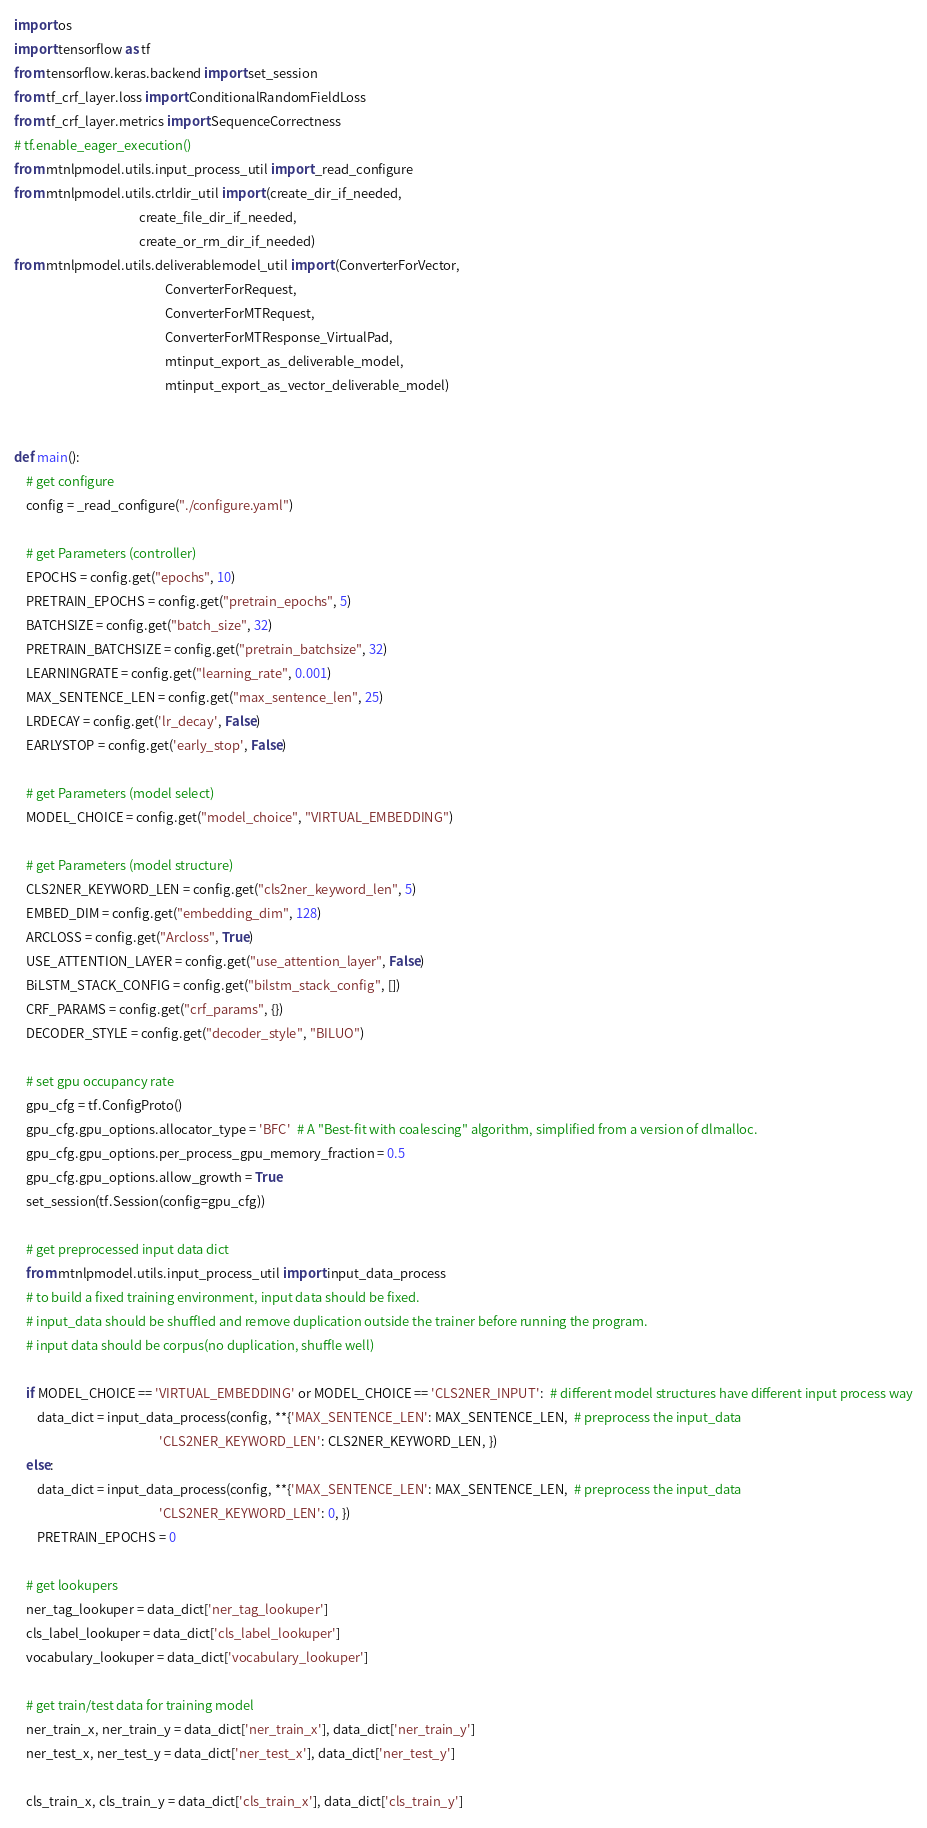Convert code to text. <code><loc_0><loc_0><loc_500><loc_500><_Python_>import os
import tensorflow as tf
from tensorflow.keras.backend import set_session
from tf_crf_layer.loss import ConditionalRandomFieldLoss
from tf_crf_layer.metrics import SequenceCorrectness
# tf.enable_eager_execution()
from mtnlpmodel.utils.input_process_util import _read_configure
from mtnlpmodel.utils.ctrldir_util import (create_dir_if_needed,
                                           create_file_dir_if_needed,
                                           create_or_rm_dir_if_needed)
from mtnlpmodel.utils.deliverablemodel_util import (ConverterForVector,
                                                    ConverterForRequest,
                                                    ConverterForMTRequest,
                                                    ConverterForMTResponse_VirtualPad,
                                                    mtinput_export_as_deliverable_model,
                                                    mtinput_export_as_vector_deliverable_model)


def main():
    # get configure
    config = _read_configure("./configure.yaml")

    # get Parameters (controller)
    EPOCHS = config.get("epochs", 10)
    PRETRAIN_EPOCHS = config.get("pretrain_epochs", 5)
    BATCHSIZE = config.get("batch_size", 32)
    PRETRAIN_BATCHSIZE = config.get("pretrain_batchsize", 32)
    LEARNINGRATE = config.get("learning_rate", 0.001)
    MAX_SENTENCE_LEN = config.get("max_sentence_len", 25)
    LRDECAY = config.get('lr_decay', False)
    EARLYSTOP = config.get('early_stop', False)

    # get Parameters (model select)
    MODEL_CHOICE = config.get("model_choice", "VIRTUAL_EMBEDDING")

    # get Parameters (model structure)
    CLS2NER_KEYWORD_LEN = config.get("cls2ner_keyword_len", 5)
    EMBED_DIM = config.get("embedding_dim", 128)
    ARCLOSS = config.get("Arcloss", True)
    USE_ATTENTION_LAYER = config.get("use_attention_layer", False)
    BiLSTM_STACK_CONFIG = config.get("bilstm_stack_config", [])
    CRF_PARAMS = config.get("crf_params", {})
    DECODER_STYLE = config.get("decoder_style", "BILUO")

    # set gpu occupancy rate
    gpu_cfg = tf.ConfigProto()
    gpu_cfg.gpu_options.allocator_type = 'BFC'  # A "Best-fit with coalescing" algorithm, simplified from a version of dlmalloc.
    gpu_cfg.gpu_options.per_process_gpu_memory_fraction = 0.5
    gpu_cfg.gpu_options.allow_growth = True
    set_session(tf.Session(config=gpu_cfg))

    # get preprocessed input data dict
    from mtnlpmodel.utils.input_process_util import input_data_process
    # to build a fixed training environment, input data should be fixed.
    # input_data should be shuffled and remove duplication outside the trainer before running the program.
    # input data should be corpus(no duplication, shuffle well)

    if MODEL_CHOICE == 'VIRTUAL_EMBEDDING' or MODEL_CHOICE == 'CLS2NER_INPUT':  # different model structures have different input process way
        data_dict = input_data_process(config, **{'MAX_SENTENCE_LEN': MAX_SENTENCE_LEN,  # preprocess the input_data
                                                  'CLS2NER_KEYWORD_LEN': CLS2NER_KEYWORD_LEN, })
    else:
        data_dict = input_data_process(config, **{'MAX_SENTENCE_LEN': MAX_SENTENCE_LEN,  # preprocess the input_data
                                                  'CLS2NER_KEYWORD_LEN': 0, })
        PRETRAIN_EPOCHS = 0

    # get lookupers
    ner_tag_lookuper = data_dict['ner_tag_lookuper']
    cls_label_lookuper = data_dict['cls_label_lookuper']
    vocabulary_lookuper = data_dict['vocabulary_lookuper']

    # get train/test data for training model
    ner_train_x, ner_train_y = data_dict['ner_train_x'], data_dict['ner_train_y']
    ner_test_x, ner_test_y = data_dict['ner_test_x'], data_dict['ner_test_y']

    cls_train_x, cls_train_y = data_dict['cls_train_x'], data_dict['cls_train_y']</code> 